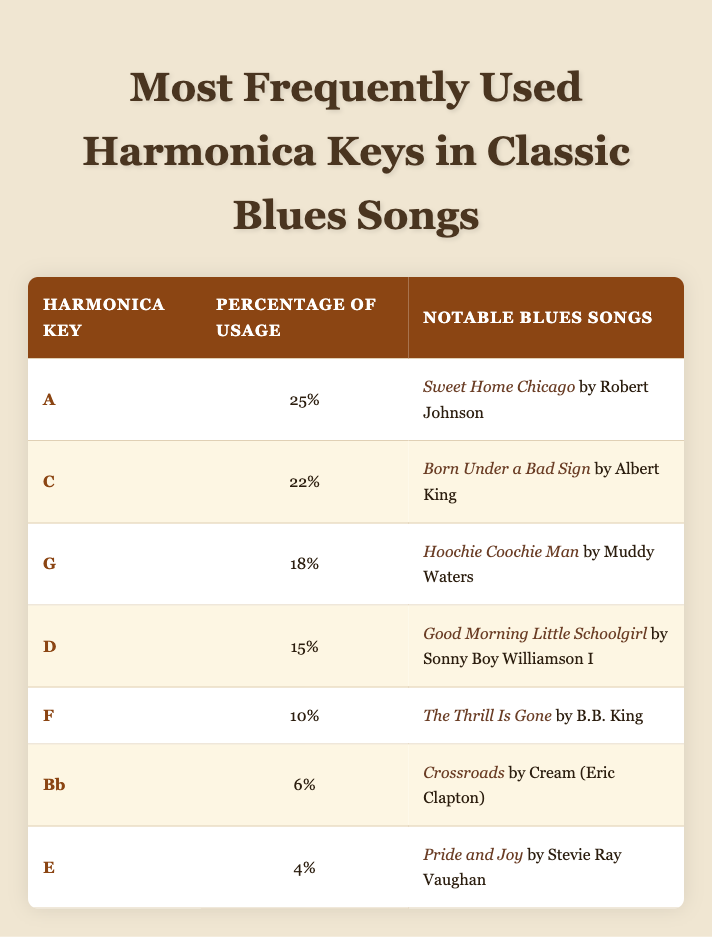What is the most frequently used harmonica key in classic blues songs? The table shows that the most frequently used harmonica key is "A," with a usage percentage of 25%.
Answer: A Which harmonica key is used in the song "The Thrill Is Gone"? According to the table, "The Thrill Is Gone" is associated with the harmonica key "F."
Answer: F What percentage of usage does the key "C" have compared to the key "G"? The key "C" has a usage percentage of 22%, while "G" has a percentage of 18%. To find the difference, we calculate 22% - 18% = 4%.
Answer: 4% Are there more notable songs listed for the key "D" than for the key "E"? The table lists one notable song for key "D" and one for key "E." Thus, the answer is no, as both have the same count.
Answer: No What is the total percentage usage of the keys "A" and "C" combined? The percentage for key "A" is 25% and for key "C" it is 22%. Adding these together gives us 25% + 22% = 47%.
Answer: 47% Which key has a lower percentage, "Bb" or "E"? The key "Bb" has a percentage of 6% and "E" has a percentage of 4%. Since 4% is less than 6%, "E" has a lower percentage.
Answer: E What is the average percentage usage of all the harmonica keys listed? To find the average, we sum up all the usage percentages: 25% + 22% + 18% + 15% + 10% + 6% + 4% = 100%. There are 7 keys, so the average is 100% / 7 = approximately 14.29%.
Answer: 14.29% Is "Sweet Home Chicago" associated with a harmonica key that has more than 20% usage? The table indicates that "Sweet Home Chicago" is associated with the key "A," which has a usage of 25%. Therefore, the answer is yes.
Answer: Yes 